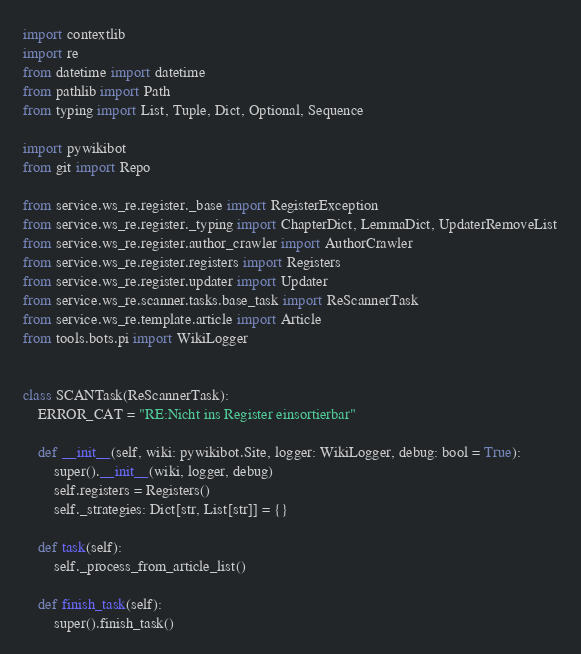<code> <loc_0><loc_0><loc_500><loc_500><_Python_>import contextlib
import re
from datetime import datetime
from pathlib import Path
from typing import List, Tuple, Dict, Optional, Sequence

import pywikibot
from git import Repo

from service.ws_re.register._base import RegisterException
from service.ws_re.register._typing import ChapterDict, LemmaDict, UpdaterRemoveList
from service.ws_re.register.author_crawler import AuthorCrawler
from service.ws_re.register.registers import Registers
from service.ws_re.register.updater import Updater
from service.ws_re.scanner.tasks.base_task import ReScannerTask
from service.ws_re.template.article import Article
from tools.bots.pi import WikiLogger


class SCANTask(ReScannerTask):
    ERROR_CAT = "RE:Nicht ins Register einsortierbar"

    def __init__(self, wiki: pywikibot.Site, logger: WikiLogger, debug: bool = True):
        super().__init__(wiki, logger, debug)
        self.registers = Registers()
        self._strategies: Dict[str, List[str]] = {}

    def task(self):
        self._process_from_article_list()

    def finish_task(self):
        super().finish_task()</code> 